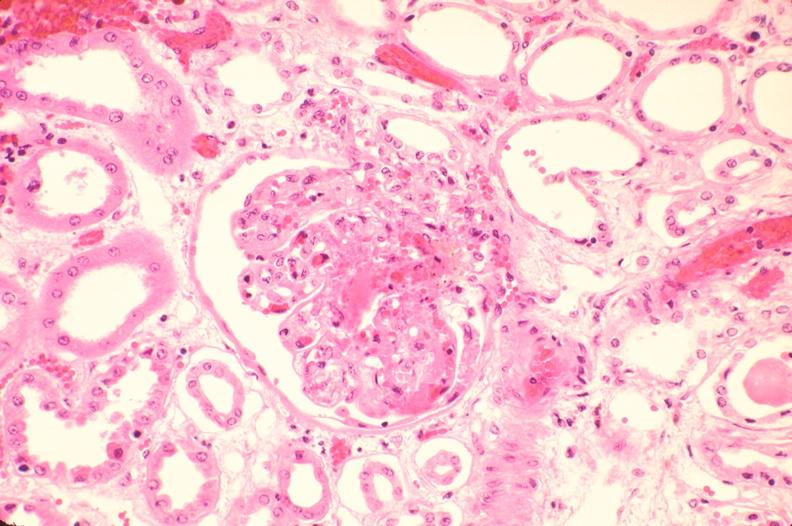what does this image show?
Answer the question using a single word or phrase. Kidney 